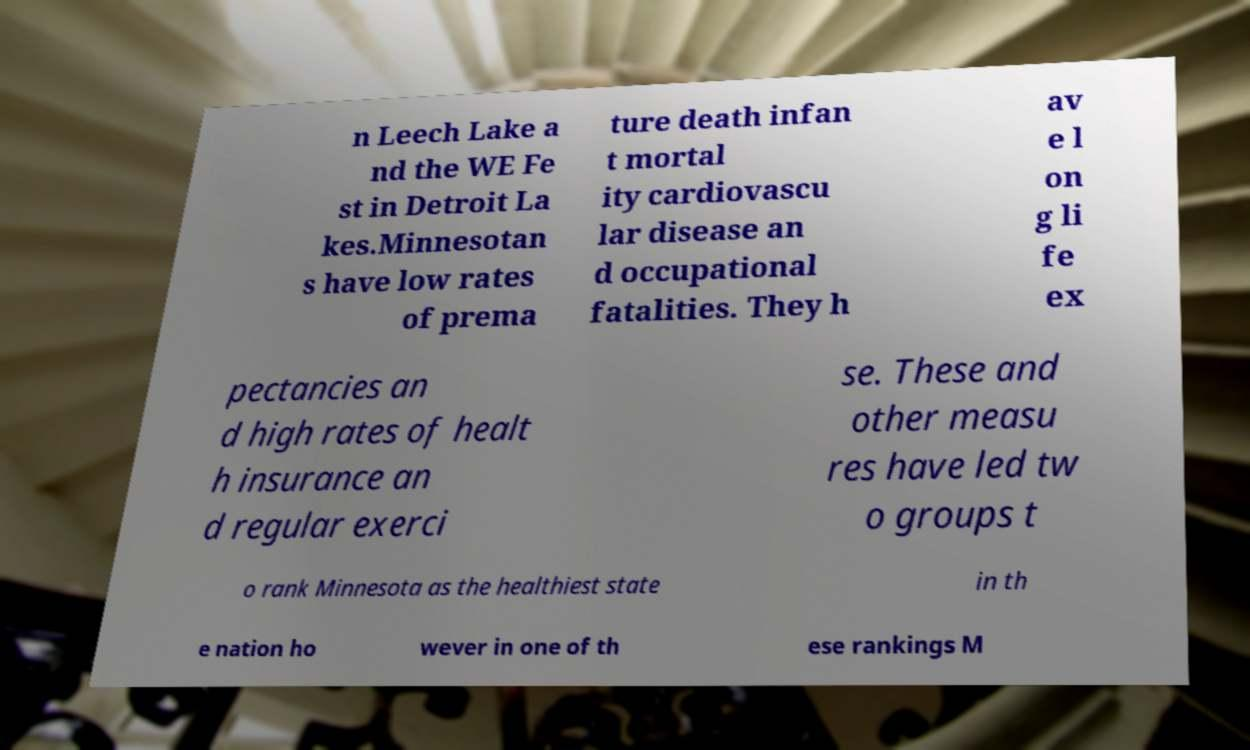For documentation purposes, I need the text within this image transcribed. Could you provide that? n Leech Lake a nd the WE Fe st in Detroit La kes.Minnesotan s have low rates of prema ture death infan t mortal ity cardiovascu lar disease an d occupational fatalities. They h av e l on g li fe ex pectancies an d high rates of healt h insurance an d regular exerci se. These and other measu res have led tw o groups t o rank Minnesota as the healthiest state in th e nation ho wever in one of th ese rankings M 